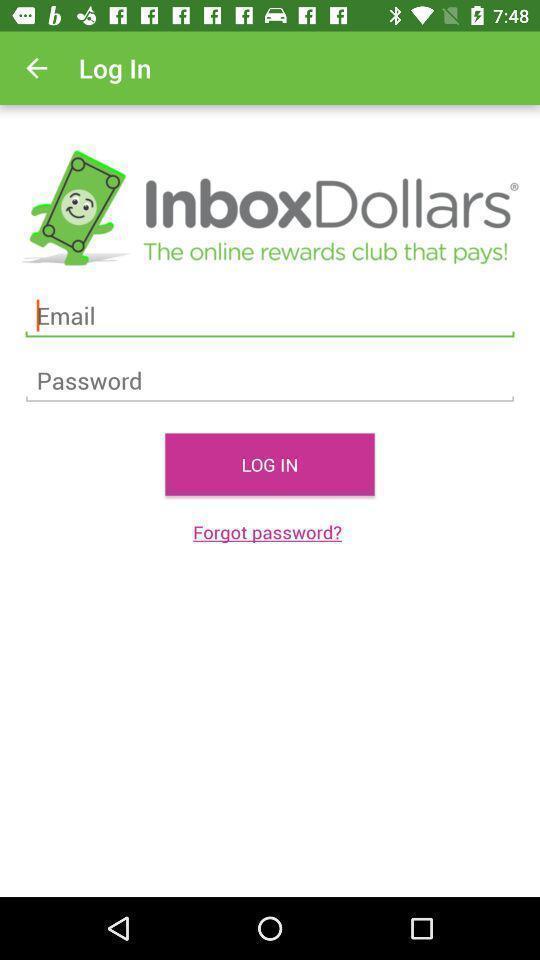Summarize the main components in this picture. Login page of a marketing app. 